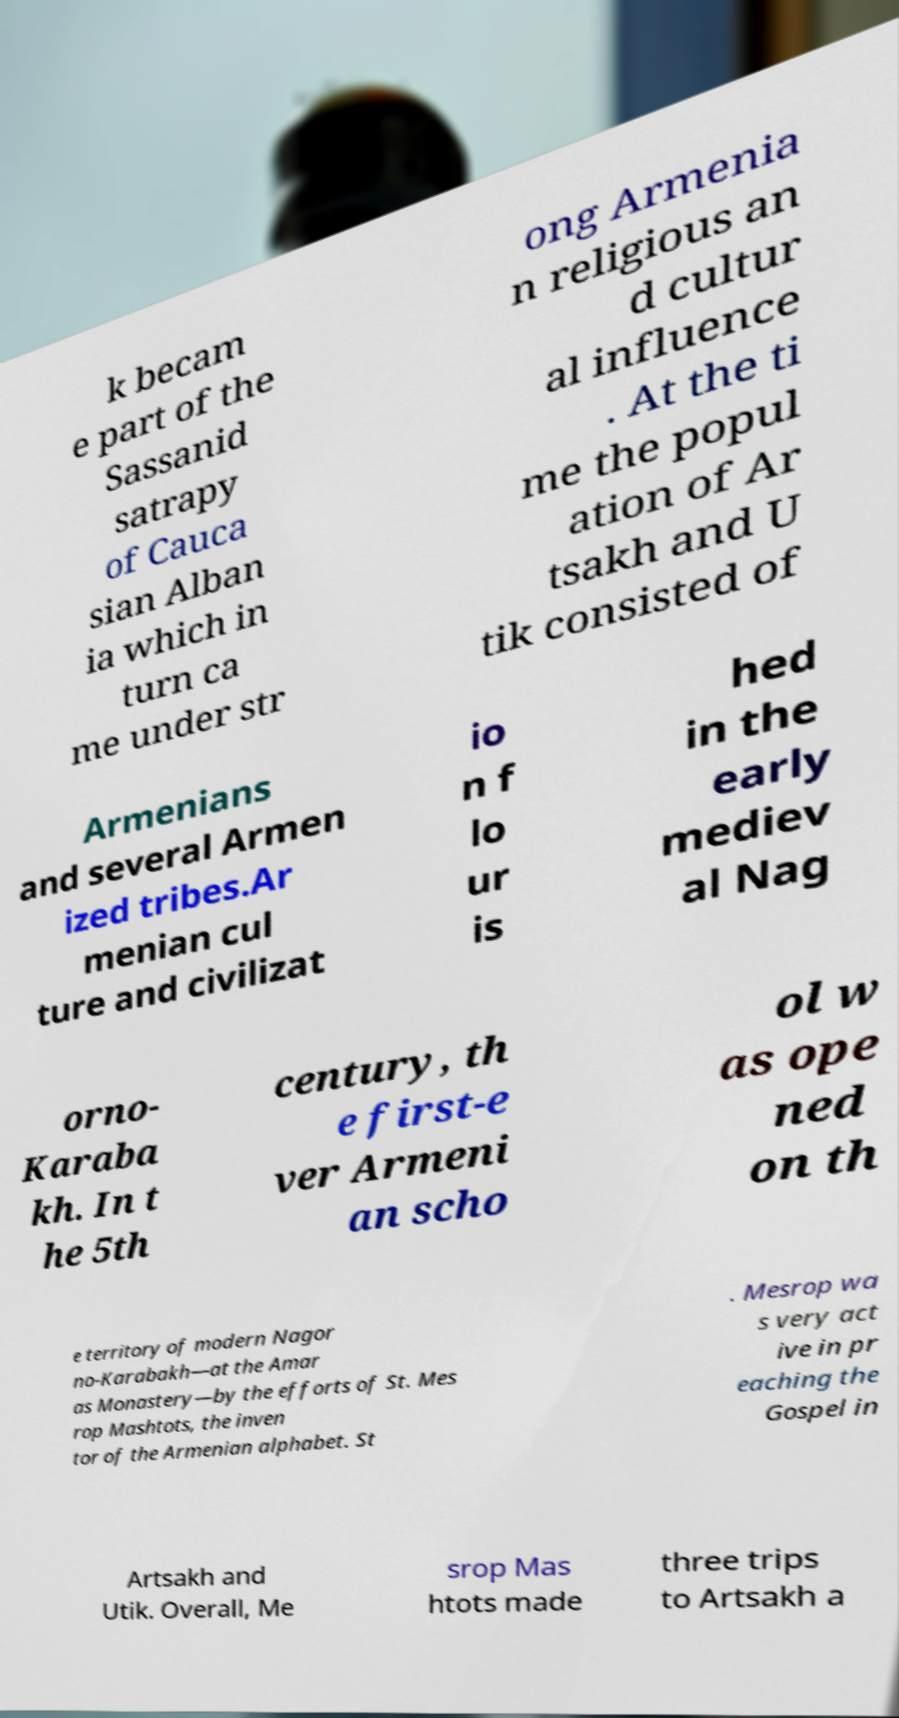Please read and relay the text visible in this image. What does it say? k becam e part of the Sassanid satrapy of Cauca sian Alban ia which in turn ca me under str ong Armenia n religious an d cultur al influence . At the ti me the popul ation of Ar tsakh and U tik consisted of Armenians and several Armen ized tribes.Ar menian cul ture and civilizat io n f lo ur is hed in the early mediev al Nag orno- Karaba kh. In t he 5th century, th e first-e ver Armeni an scho ol w as ope ned on th e territory of modern Nagor no-Karabakh—at the Amar as Monastery—by the efforts of St. Mes rop Mashtots, the inven tor of the Armenian alphabet. St . Mesrop wa s very act ive in pr eaching the Gospel in Artsakh and Utik. Overall, Me srop Mas htots made three trips to Artsakh a 